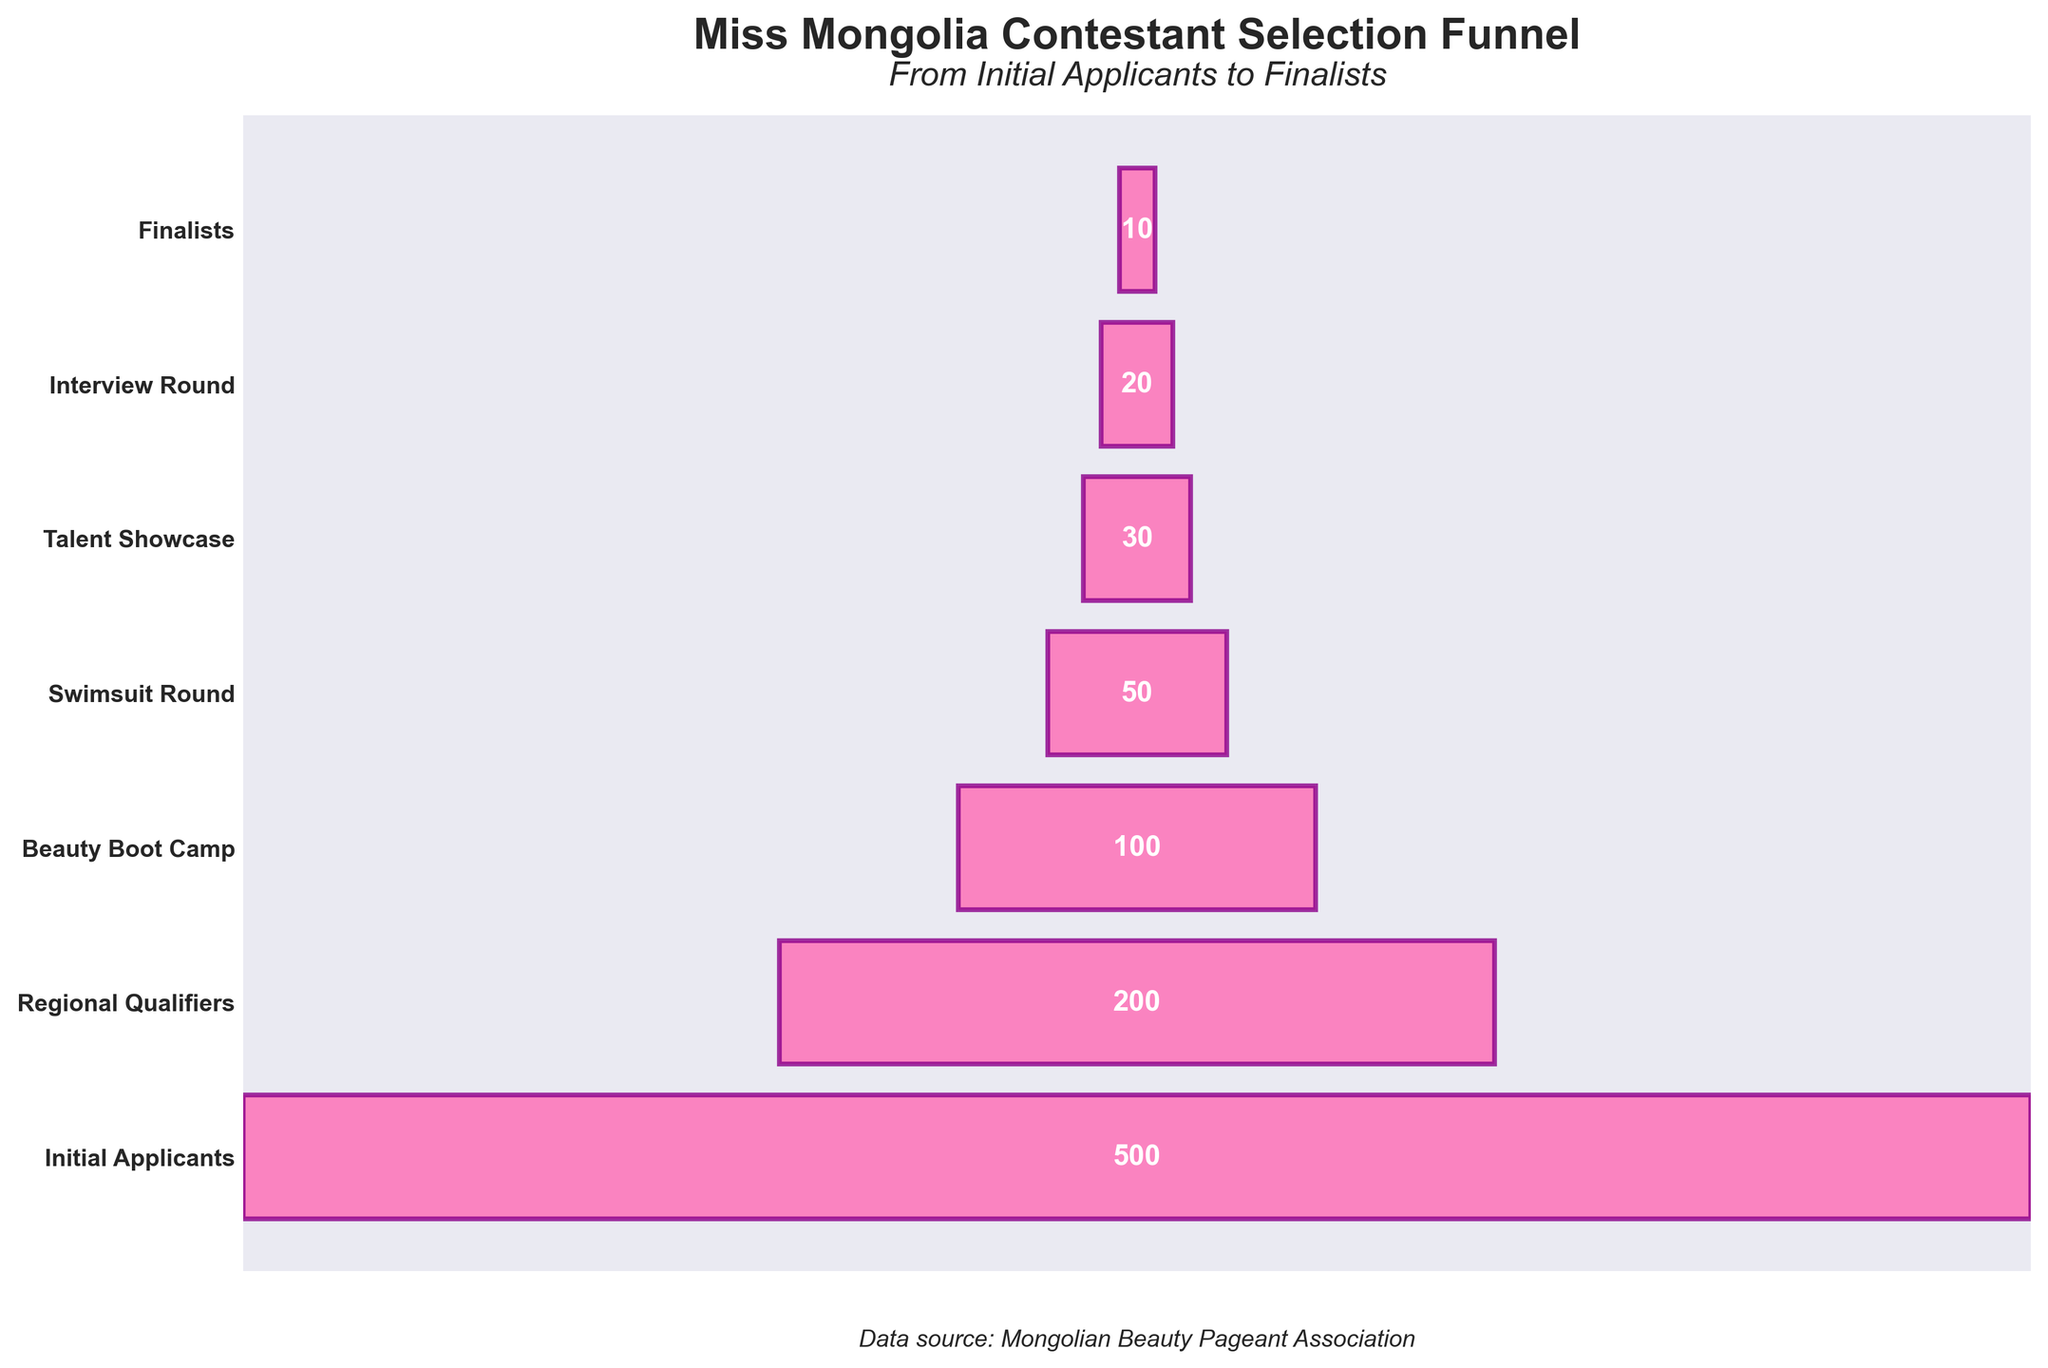How many contestants participated in the Swimsuit Round? Look at the Swimsuit Round stage on the y-axis and read the number of contestants right beside it.
Answer: 50 What is the title of the funnel chart? The title is positioned at the top of the chart. It can be identified through larger and bolded text.
Answer: Miss Mongolia Contestant Selection Funnel How many contestants advanced from the Regional Qualifiers stage to the Beauty Boot Camp stage? The number of contestants in the Regional Qualifiers stage is 200, and in the Beauty Boot Camp stage is 100. The difference between these two stages gives us the number of contestants who advanced.
Answer: 100 Which stage has the fewest contestants? Compare the number of contestants at each stage and identify the one with the smallest number. The Finalists stage has the fewest contestants.
Answer: Finalists How many contestants were eliminated between the Talent Showcase and the Interview Round? Look at the number of contestants in the Talent Showcase stage (30) and the Interview Round stage (20). The difference between these numbers will give the contestants eliminated.
Answer: 10 What is the subtitle of the chart? The subtitle is generally found just below the main title. Look for a slightly smaller font size.
Answer: From Initial Applicants to Finalists What stage comes immediately before the Swimsuit Round in the funnel? Trace the stage sequence from the beginning and identify the stage listed right before the Swimsuit Round.
Answer: Beauty Boot Camp How many stages are there in the contestant selection process? Count the unique stages listed on the y-axis from the top to the bottom.
Answer: 7 How many contestants in total made it through to the Interview Round and beyond? Examine the number of contestants starting from the Interview Round stage (20) and add the total to the Finalists stage (10). The sum will give the total number of contestants from the Interview Round onwards.
Answer: 20 + 10 = 30 Which stage had exactly a 50% reduction in contestants compared to the previous stage? To find where the number of contestants halved, sequentially divide the number of contestants in each stage by the number in the previous stage and check for a quotient of 0.5. Beauty Boot Camp to the Swimsuit Round and the Initial Applicants to the Regional Qualifiers both fit this criterion but choosing one, say Beauty Boot Camp to the Swimsuit Round.
Answer: Swimsuit Round 